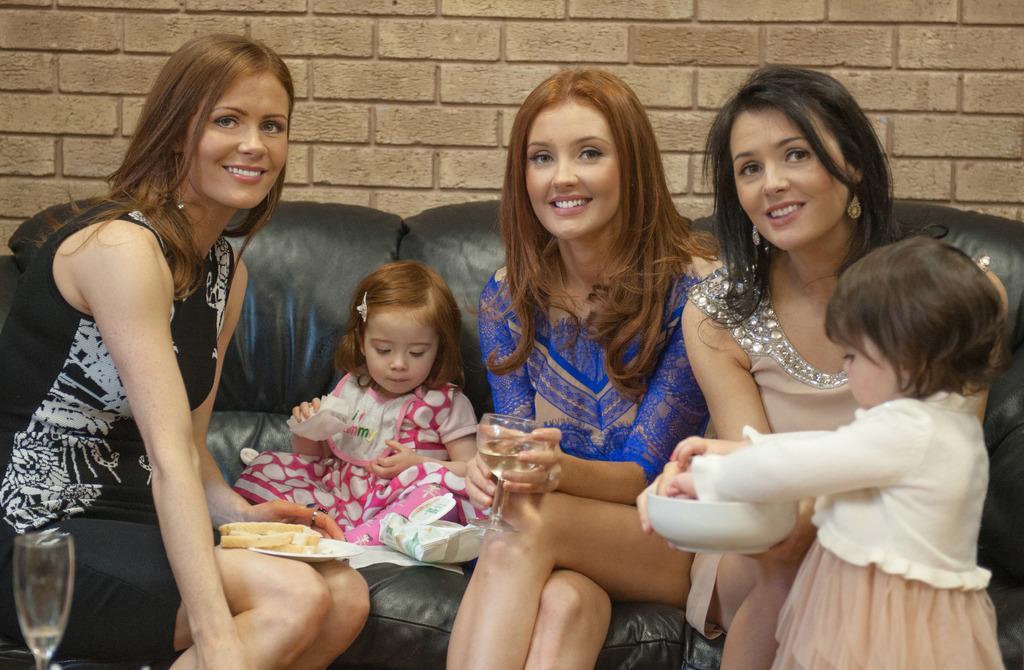Could you give a brief overview of what you see in this image? In this image there are three persons and a girl are sitting on the couch, there are bread slices on the plate, a girl holding a tissue, another girl holding a bowl , a person holding a glass, and in the background there is a wall. 